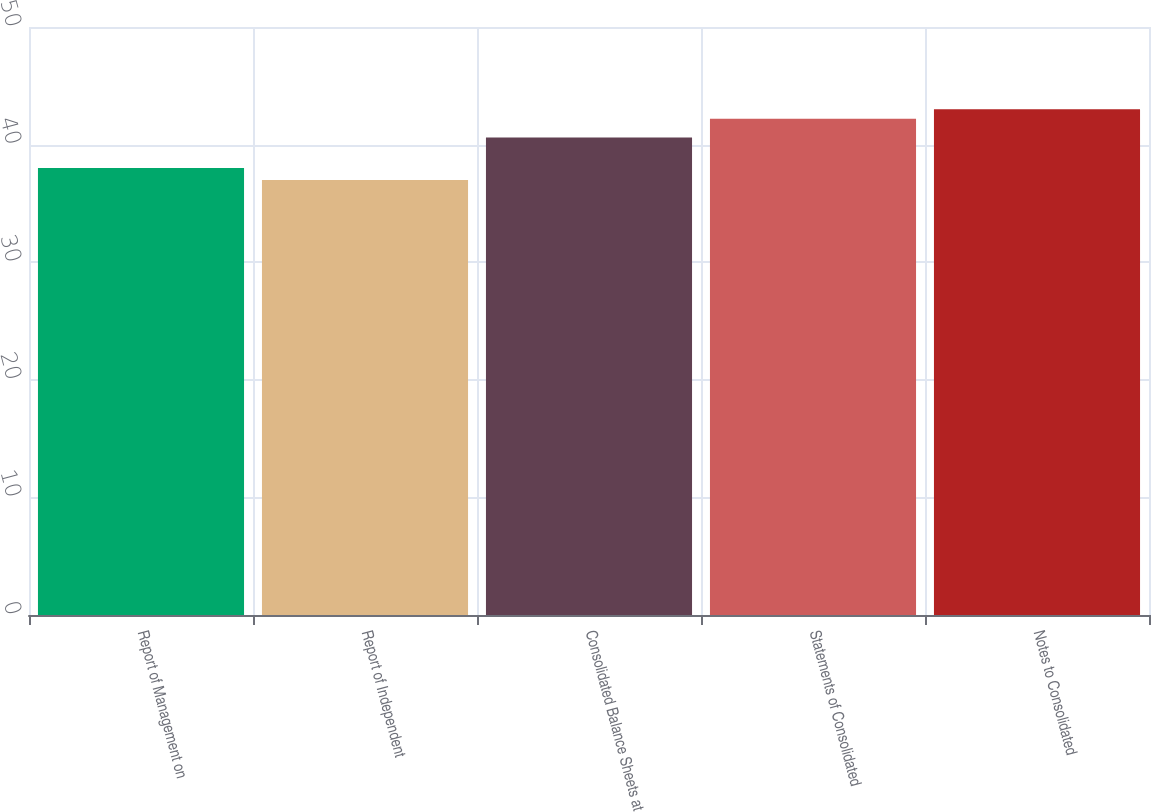<chart> <loc_0><loc_0><loc_500><loc_500><bar_chart><fcel>Report of Management on<fcel>Report of Independent<fcel>Consolidated Balance Sheets at<fcel>Statements of Consolidated<fcel>Notes to Consolidated<nl><fcel>38<fcel>37<fcel>40.6<fcel>42.2<fcel>43<nl></chart> 